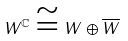Convert formula to latex. <formula><loc_0><loc_0><loc_500><loc_500>W ^ { \mathbb { C } } \cong W \oplus \overline { W }</formula> 